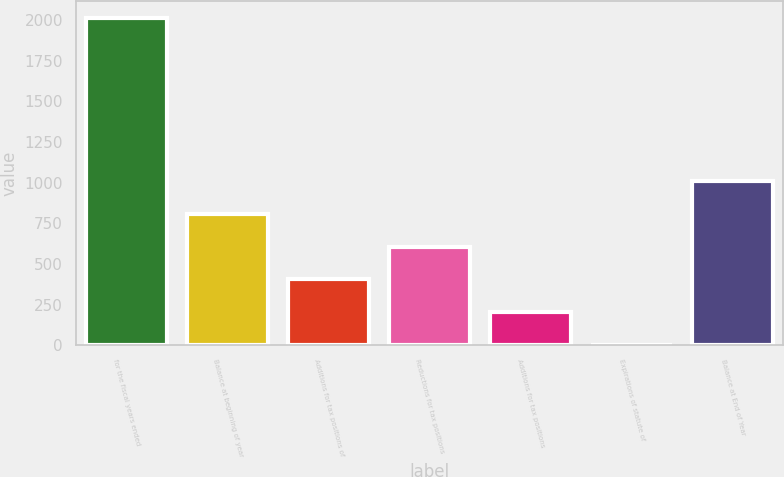Convert chart. <chart><loc_0><loc_0><loc_500><loc_500><bar_chart><fcel>for the fiscal years ended<fcel>Balance at beginning of year<fcel>Additions for tax positions of<fcel>Reductions for tax positions<fcel>Additions for tax positions<fcel>Expirations of statute of<fcel>Balance at End of Year<nl><fcel>2013<fcel>807.96<fcel>406.28<fcel>607.12<fcel>205.44<fcel>4.6<fcel>1008.8<nl></chart> 